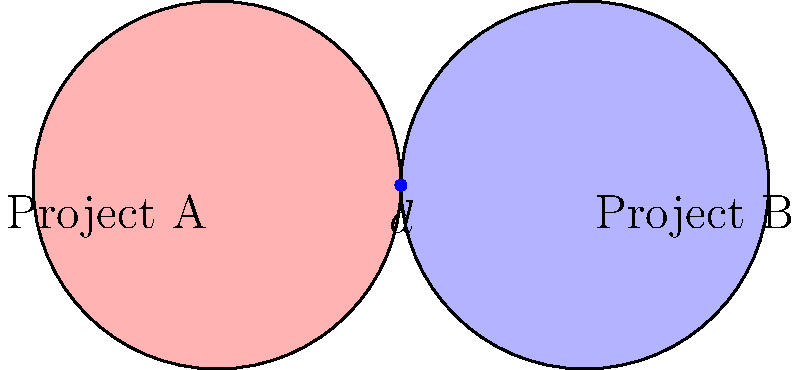In a resource allocation Venn diagram for two projects, each circle represents the total resources allocated to a project. The circles have a radius of 2 units and their centers are 4 units apart. Calculate the area of the overlapping region (shared resources) to the nearest hundredth. How might this information be useful in a grant proposal for resource optimization? To calculate the area of the overlapping region, we'll follow these steps:

1) First, we need to find the area of the lens-shaped overlap. The formula for this is:

   $A = 2r^2 \arccos(\frac{d}{2r}) - d\sqrt{r^2 - (\frac{d}{2})^2}$

   Where $r$ is the radius of each circle and $d$ is the distance between their centers.

2) We're given that $r = 2$ and $d = 4$. Let's substitute these values:

   $A = 2(2^2) \arccos(\frac{4}{2(2)}) - 4\sqrt{2^2 - (\frac{4}{2})^2}$

3) Simplify:
   $A = 8 \arccos(\frac{1}{2}) - 4\sqrt{4 - 4}$
   $A = 8 \arccos(0.5) - 4\sqrt{0}$
   $A = 8 \arccos(0.5) - 0$
   $A = 8 \arccos(0.5)$

4) Calculate:
   $\arccos(0.5) \approx 1.0472$ radians
   $A \approx 8 * 1.0472 \approx 8.3776$ square units

5) Rounding to the nearest hundredth:
   $A \approx 8.38$ square units

This information is valuable in a grant proposal for resource optimization as it quantifies the extent of shared resources between projects. It can help in:
- Demonstrating efficient use of resources across multiple projects
- Identifying potential areas for cost savings
- Highlighting collaborative efforts and synergies between projects
- Providing a data-driven approach to resource allocation strategies
Answer: 8.38 square units 